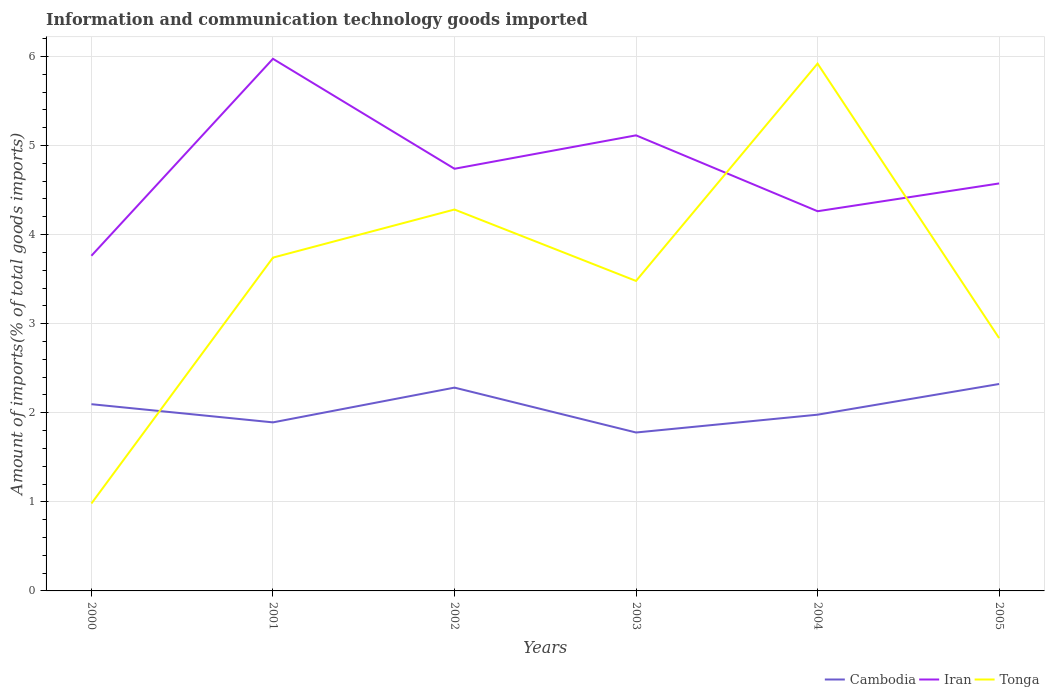Does the line corresponding to Iran intersect with the line corresponding to Cambodia?
Keep it short and to the point. No. Is the number of lines equal to the number of legend labels?
Your answer should be very brief. Yes. Across all years, what is the maximum amount of goods imported in Cambodia?
Make the answer very short. 1.78. What is the total amount of goods imported in Cambodia in the graph?
Make the answer very short. -0.54. What is the difference between the highest and the second highest amount of goods imported in Iran?
Give a very brief answer. 2.21. Is the amount of goods imported in Iran strictly greater than the amount of goods imported in Cambodia over the years?
Your answer should be very brief. No. How many lines are there?
Your answer should be compact. 3. What is the difference between two consecutive major ticks on the Y-axis?
Provide a succinct answer. 1. Where does the legend appear in the graph?
Ensure brevity in your answer.  Bottom right. How many legend labels are there?
Ensure brevity in your answer.  3. What is the title of the graph?
Make the answer very short. Information and communication technology goods imported. What is the label or title of the Y-axis?
Offer a terse response. Amount of imports(% of total goods imports). What is the Amount of imports(% of total goods imports) of Cambodia in 2000?
Provide a succinct answer. 2.1. What is the Amount of imports(% of total goods imports) in Iran in 2000?
Your answer should be very brief. 3.76. What is the Amount of imports(% of total goods imports) of Tonga in 2000?
Make the answer very short. 0.98. What is the Amount of imports(% of total goods imports) in Cambodia in 2001?
Your answer should be compact. 1.89. What is the Amount of imports(% of total goods imports) of Iran in 2001?
Your response must be concise. 5.97. What is the Amount of imports(% of total goods imports) of Tonga in 2001?
Your response must be concise. 3.74. What is the Amount of imports(% of total goods imports) of Cambodia in 2002?
Give a very brief answer. 2.28. What is the Amount of imports(% of total goods imports) in Iran in 2002?
Give a very brief answer. 4.74. What is the Amount of imports(% of total goods imports) of Tonga in 2002?
Give a very brief answer. 4.28. What is the Amount of imports(% of total goods imports) of Cambodia in 2003?
Offer a very short reply. 1.78. What is the Amount of imports(% of total goods imports) of Iran in 2003?
Offer a terse response. 5.11. What is the Amount of imports(% of total goods imports) of Tonga in 2003?
Ensure brevity in your answer.  3.48. What is the Amount of imports(% of total goods imports) of Cambodia in 2004?
Your answer should be compact. 1.98. What is the Amount of imports(% of total goods imports) in Iran in 2004?
Offer a very short reply. 4.26. What is the Amount of imports(% of total goods imports) in Tonga in 2004?
Keep it short and to the point. 5.92. What is the Amount of imports(% of total goods imports) in Cambodia in 2005?
Your answer should be compact. 2.32. What is the Amount of imports(% of total goods imports) in Iran in 2005?
Offer a terse response. 4.57. What is the Amount of imports(% of total goods imports) in Tonga in 2005?
Make the answer very short. 2.84. Across all years, what is the maximum Amount of imports(% of total goods imports) in Cambodia?
Your answer should be very brief. 2.32. Across all years, what is the maximum Amount of imports(% of total goods imports) of Iran?
Your answer should be compact. 5.97. Across all years, what is the maximum Amount of imports(% of total goods imports) of Tonga?
Ensure brevity in your answer.  5.92. Across all years, what is the minimum Amount of imports(% of total goods imports) of Cambodia?
Make the answer very short. 1.78. Across all years, what is the minimum Amount of imports(% of total goods imports) in Iran?
Keep it short and to the point. 3.76. Across all years, what is the minimum Amount of imports(% of total goods imports) of Tonga?
Your response must be concise. 0.98. What is the total Amount of imports(% of total goods imports) of Cambodia in the graph?
Provide a succinct answer. 12.35. What is the total Amount of imports(% of total goods imports) in Iran in the graph?
Your answer should be very brief. 28.43. What is the total Amount of imports(% of total goods imports) in Tonga in the graph?
Make the answer very short. 21.24. What is the difference between the Amount of imports(% of total goods imports) in Cambodia in 2000 and that in 2001?
Keep it short and to the point. 0.2. What is the difference between the Amount of imports(% of total goods imports) of Iran in 2000 and that in 2001?
Offer a very short reply. -2.21. What is the difference between the Amount of imports(% of total goods imports) of Tonga in 2000 and that in 2001?
Keep it short and to the point. -2.76. What is the difference between the Amount of imports(% of total goods imports) in Cambodia in 2000 and that in 2002?
Offer a very short reply. -0.19. What is the difference between the Amount of imports(% of total goods imports) of Iran in 2000 and that in 2002?
Your response must be concise. -0.98. What is the difference between the Amount of imports(% of total goods imports) of Tonga in 2000 and that in 2002?
Ensure brevity in your answer.  -3.3. What is the difference between the Amount of imports(% of total goods imports) in Cambodia in 2000 and that in 2003?
Provide a short and direct response. 0.32. What is the difference between the Amount of imports(% of total goods imports) in Iran in 2000 and that in 2003?
Give a very brief answer. -1.35. What is the difference between the Amount of imports(% of total goods imports) of Tonga in 2000 and that in 2003?
Your response must be concise. -2.5. What is the difference between the Amount of imports(% of total goods imports) of Cambodia in 2000 and that in 2004?
Offer a very short reply. 0.12. What is the difference between the Amount of imports(% of total goods imports) of Tonga in 2000 and that in 2004?
Provide a succinct answer. -4.94. What is the difference between the Amount of imports(% of total goods imports) in Cambodia in 2000 and that in 2005?
Offer a terse response. -0.23. What is the difference between the Amount of imports(% of total goods imports) in Iran in 2000 and that in 2005?
Give a very brief answer. -0.81. What is the difference between the Amount of imports(% of total goods imports) of Tonga in 2000 and that in 2005?
Offer a terse response. -1.86. What is the difference between the Amount of imports(% of total goods imports) of Cambodia in 2001 and that in 2002?
Keep it short and to the point. -0.39. What is the difference between the Amount of imports(% of total goods imports) in Iran in 2001 and that in 2002?
Give a very brief answer. 1.23. What is the difference between the Amount of imports(% of total goods imports) of Tonga in 2001 and that in 2002?
Your answer should be compact. -0.54. What is the difference between the Amount of imports(% of total goods imports) in Cambodia in 2001 and that in 2003?
Keep it short and to the point. 0.11. What is the difference between the Amount of imports(% of total goods imports) of Iran in 2001 and that in 2003?
Provide a succinct answer. 0.86. What is the difference between the Amount of imports(% of total goods imports) of Tonga in 2001 and that in 2003?
Provide a short and direct response. 0.26. What is the difference between the Amount of imports(% of total goods imports) of Cambodia in 2001 and that in 2004?
Ensure brevity in your answer.  -0.09. What is the difference between the Amount of imports(% of total goods imports) in Iran in 2001 and that in 2004?
Keep it short and to the point. 1.71. What is the difference between the Amount of imports(% of total goods imports) in Tonga in 2001 and that in 2004?
Offer a very short reply. -2.18. What is the difference between the Amount of imports(% of total goods imports) of Cambodia in 2001 and that in 2005?
Ensure brevity in your answer.  -0.43. What is the difference between the Amount of imports(% of total goods imports) of Iran in 2001 and that in 2005?
Your answer should be very brief. 1.4. What is the difference between the Amount of imports(% of total goods imports) of Tonga in 2001 and that in 2005?
Make the answer very short. 0.9. What is the difference between the Amount of imports(% of total goods imports) of Cambodia in 2002 and that in 2003?
Your answer should be compact. 0.5. What is the difference between the Amount of imports(% of total goods imports) in Iran in 2002 and that in 2003?
Make the answer very short. -0.38. What is the difference between the Amount of imports(% of total goods imports) in Tonga in 2002 and that in 2003?
Give a very brief answer. 0.8. What is the difference between the Amount of imports(% of total goods imports) of Cambodia in 2002 and that in 2004?
Give a very brief answer. 0.3. What is the difference between the Amount of imports(% of total goods imports) in Iran in 2002 and that in 2004?
Keep it short and to the point. 0.48. What is the difference between the Amount of imports(% of total goods imports) in Tonga in 2002 and that in 2004?
Ensure brevity in your answer.  -1.64. What is the difference between the Amount of imports(% of total goods imports) in Cambodia in 2002 and that in 2005?
Your answer should be very brief. -0.04. What is the difference between the Amount of imports(% of total goods imports) of Iran in 2002 and that in 2005?
Offer a terse response. 0.16. What is the difference between the Amount of imports(% of total goods imports) of Tonga in 2002 and that in 2005?
Ensure brevity in your answer.  1.44. What is the difference between the Amount of imports(% of total goods imports) in Cambodia in 2003 and that in 2004?
Provide a short and direct response. -0.2. What is the difference between the Amount of imports(% of total goods imports) in Iran in 2003 and that in 2004?
Provide a succinct answer. 0.85. What is the difference between the Amount of imports(% of total goods imports) in Tonga in 2003 and that in 2004?
Provide a succinct answer. -2.44. What is the difference between the Amount of imports(% of total goods imports) in Cambodia in 2003 and that in 2005?
Offer a terse response. -0.54. What is the difference between the Amount of imports(% of total goods imports) of Iran in 2003 and that in 2005?
Give a very brief answer. 0.54. What is the difference between the Amount of imports(% of total goods imports) in Tonga in 2003 and that in 2005?
Keep it short and to the point. 0.64. What is the difference between the Amount of imports(% of total goods imports) of Cambodia in 2004 and that in 2005?
Provide a short and direct response. -0.34. What is the difference between the Amount of imports(% of total goods imports) of Iran in 2004 and that in 2005?
Provide a succinct answer. -0.31. What is the difference between the Amount of imports(% of total goods imports) of Tonga in 2004 and that in 2005?
Provide a short and direct response. 3.08. What is the difference between the Amount of imports(% of total goods imports) of Cambodia in 2000 and the Amount of imports(% of total goods imports) of Iran in 2001?
Offer a terse response. -3.88. What is the difference between the Amount of imports(% of total goods imports) of Cambodia in 2000 and the Amount of imports(% of total goods imports) of Tonga in 2001?
Offer a very short reply. -1.65. What is the difference between the Amount of imports(% of total goods imports) in Iran in 2000 and the Amount of imports(% of total goods imports) in Tonga in 2001?
Offer a very short reply. 0.02. What is the difference between the Amount of imports(% of total goods imports) of Cambodia in 2000 and the Amount of imports(% of total goods imports) of Iran in 2002?
Give a very brief answer. -2.64. What is the difference between the Amount of imports(% of total goods imports) of Cambodia in 2000 and the Amount of imports(% of total goods imports) of Tonga in 2002?
Your response must be concise. -2.19. What is the difference between the Amount of imports(% of total goods imports) in Iran in 2000 and the Amount of imports(% of total goods imports) in Tonga in 2002?
Give a very brief answer. -0.52. What is the difference between the Amount of imports(% of total goods imports) in Cambodia in 2000 and the Amount of imports(% of total goods imports) in Iran in 2003?
Make the answer very short. -3.02. What is the difference between the Amount of imports(% of total goods imports) of Cambodia in 2000 and the Amount of imports(% of total goods imports) of Tonga in 2003?
Provide a succinct answer. -1.38. What is the difference between the Amount of imports(% of total goods imports) in Iran in 2000 and the Amount of imports(% of total goods imports) in Tonga in 2003?
Make the answer very short. 0.28. What is the difference between the Amount of imports(% of total goods imports) of Cambodia in 2000 and the Amount of imports(% of total goods imports) of Iran in 2004?
Offer a terse response. -2.17. What is the difference between the Amount of imports(% of total goods imports) in Cambodia in 2000 and the Amount of imports(% of total goods imports) in Tonga in 2004?
Ensure brevity in your answer.  -3.82. What is the difference between the Amount of imports(% of total goods imports) in Iran in 2000 and the Amount of imports(% of total goods imports) in Tonga in 2004?
Ensure brevity in your answer.  -2.16. What is the difference between the Amount of imports(% of total goods imports) in Cambodia in 2000 and the Amount of imports(% of total goods imports) in Iran in 2005?
Your answer should be very brief. -2.48. What is the difference between the Amount of imports(% of total goods imports) of Cambodia in 2000 and the Amount of imports(% of total goods imports) of Tonga in 2005?
Make the answer very short. -0.74. What is the difference between the Amount of imports(% of total goods imports) in Iran in 2000 and the Amount of imports(% of total goods imports) in Tonga in 2005?
Your answer should be compact. 0.92. What is the difference between the Amount of imports(% of total goods imports) in Cambodia in 2001 and the Amount of imports(% of total goods imports) in Iran in 2002?
Keep it short and to the point. -2.85. What is the difference between the Amount of imports(% of total goods imports) of Cambodia in 2001 and the Amount of imports(% of total goods imports) of Tonga in 2002?
Provide a succinct answer. -2.39. What is the difference between the Amount of imports(% of total goods imports) of Iran in 2001 and the Amount of imports(% of total goods imports) of Tonga in 2002?
Give a very brief answer. 1.69. What is the difference between the Amount of imports(% of total goods imports) in Cambodia in 2001 and the Amount of imports(% of total goods imports) in Iran in 2003?
Offer a terse response. -3.22. What is the difference between the Amount of imports(% of total goods imports) of Cambodia in 2001 and the Amount of imports(% of total goods imports) of Tonga in 2003?
Your response must be concise. -1.59. What is the difference between the Amount of imports(% of total goods imports) of Iran in 2001 and the Amount of imports(% of total goods imports) of Tonga in 2003?
Your answer should be compact. 2.49. What is the difference between the Amount of imports(% of total goods imports) in Cambodia in 2001 and the Amount of imports(% of total goods imports) in Iran in 2004?
Provide a succinct answer. -2.37. What is the difference between the Amount of imports(% of total goods imports) of Cambodia in 2001 and the Amount of imports(% of total goods imports) of Tonga in 2004?
Your answer should be very brief. -4.03. What is the difference between the Amount of imports(% of total goods imports) in Iran in 2001 and the Amount of imports(% of total goods imports) in Tonga in 2004?
Provide a succinct answer. 0.05. What is the difference between the Amount of imports(% of total goods imports) of Cambodia in 2001 and the Amount of imports(% of total goods imports) of Iran in 2005?
Ensure brevity in your answer.  -2.68. What is the difference between the Amount of imports(% of total goods imports) in Cambodia in 2001 and the Amount of imports(% of total goods imports) in Tonga in 2005?
Provide a succinct answer. -0.95. What is the difference between the Amount of imports(% of total goods imports) of Iran in 2001 and the Amount of imports(% of total goods imports) of Tonga in 2005?
Make the answer very short. 3.14. What is the difference between the Amount of imports(% of total goods imports) of Cambodia in 2002 and the Amount of imports(% of total goods imports) of Iran in 2003?
Ensure brevity in your answer.  -2.83. What is the difference between the Amount of imports(% of total goods imports) in Cambodia in 2002 and the Amount of imports(% of total goods imports) in Tonga in 2003?
Provide a short and direct response. -1.2. What is the difference between the Amount of imports(% of total goods imports) of Iran in 2002 and the Amount of imports(% of total goods imports) of Tonga in 2003?
Your answer should be very brief. 1.26. What is the difference between the Amount of imports(% of total goods imports) in Cambodia in 2002 and the Amount of imports(% of total goods imports) in Iran in 2004?
Give a very brief answer. -1.98. What is the difference between the Amount of imports(% of total goods imports) in Cambodia in 2002 and the Amount of imports(% of total goods imports) in Tonga in 2004?
Your answer should be very brief. -3.64. What is the difference between the Amount of imports(% of total goods imports) of Iran in 2002 and the Amount of imports(% of total goods imports) of Tonga in 2004?
Ensure brevity in your answer.  -1.18. What is the difference between the Amount of imports(% of total goods imports) of Cambodia in 2002 and the Amount of imports(% of total goods imports) of Iran in 2005?
Offer a very short reply. -2.29. What is the difference between the Amount of imports(% of total goods imports) of Cambodia in 2002 and the Amount of imports(% of total goods imports) of Tonga in 2005?
Give a very brief answer. -0.56. What is the difference between the Amount of imports(% of total goods imports) in Iran in 2002 and the Amount of imports(% of total goods imports) in Tonga in 2005?
Provide a short and direct response. 1.9. What is the difference between the Amount of imports(% of total goods imports) of Cambodia in 2003 and the Amount of imports(% of total goods imports) of Iran in 2004?
Offer a very short reply. -2.48. What is the difference between the Amount of imports(% of total goods imports) of Cambodia in 2003 and the Amount of imports(% of total goods imports) of Tonga in 2004?
Give a very brief answer. -4.14. What is the difference between the Amount of imports(% of total goods imports) of Iran in 2003 and the Amount of imports(% of total goods imports) of Tonga in 2004?
Keep it short and to the point. -0.81. What is the difference between the Amount of imports(% of total goods imports) of Cambodia in 2003 and the Amount of imports(% of total goods imports) of Iran in 2005?
Ensure brevity in your answer.  -2.8. What is the difference between the Amount of imports(% of total goods imports) in Cambodia in 2003 and the Amount of imports(% of total goods imports) in Tonga in 2005?
Make the answer very short. -1.06. What is the difference between the Amount of imports(% of total goods imports) of Iran in 2003 and the Amount of imports(% of total goods imports) of Tonga in 2005?
Your answer should be very brief. 2.28. What is the difference between the Amount of imports(% of total goods imports) of Cambodia in 2004 and the Amount of imports(% of total goods imports) of Iran in 2005?
Keep it short and to the point. -2.6. What is the difference between the Amount of imports(% of total goods imports) in Cambodia in 2004 and the Amount of imports(% of total goods imports) in Tonga in 2005?
Offer a very short reply. -0.86. What is the difference between the Amount of imports(% of total goods imports) in Iran in 2004 and the Amount of imports(% of total goods imports) in Tonga in 2005?
Offer a very short reply. 1.42. What is the average Amount of imports(% of total goods imports) in Cambodia per year?
Offer a terse response. 2.06. What is the average Amount of imports(% of total goods imports) of Iran per year?
Make the answer very short. 4.74. What is the average Amount of imports(% of total goods imports) in Tonga per year?
Ensure brevity in your answer.  3.54. In the year 2000, what is the difference between the Amount of imports(% of total goods imports) in Cambodia and Amount of imports(% of total goods imports) in Iran?
Your response must be concise. -1.67. In the year 2000, what is the difference between the Amount of imports(% of total goods imports) in Cambodia and Amount of imports(% of total goods imports) in Tonga?
Your response must be concise. 1.11. In the year 2000, what is the difference between the Amount of imports(% of total goods imports) in Iran and Amount of imports(% of total goods imports) in Tonga?
Make the answer very short. 2.78. In the year 2001, what is the difference between the Amount of imports(% of total goods imports) in Cambodia and Amount of imports(% of total goods imports) in Iran?
Your answer should be very brief. -4.08. In the year 2001, what is the difference between the Amount of imports(% of total goods imports) in Cambodia and Amount of imports(% of total goods imports) in Tonga?
Make the answer very short. -1.85. In the year 2001, what is the difference between the Amount of imports(% of total goods imports) of Iran and Amount of imports(% of total goods imports) of Tonga?
Offer a very short reply. 2.23. In the year 2002, what is the difference between the Amount of imports(% of total goods imports) in Cambodia and Amount of imports(% of total goods imports) in Iran?
Your answer should be very brief. -2.46. In the year 2002, what is the difference between the Amount of imports(% of total goods imports) of Cambodia and Amount of imports(% of total goods imports) of Tonga?
Keep it short and to the point. -2. In the year 2002, what is the difference between the Amount of imports(% of total goods imports) in Iran and Amount of imports(% of total goods imports) in Tonga?
Your answer should be compact. 0.46. In the year 2003, what is the difference between the Amount of imports(% of total goods imports) in Cambodia and Amount of imports(% of total goods imports) in Iran?
Provide a short and direct response. -3.34. In the year 2003, what is the difference between the Amount of imports(% of total goods imports) of Cambodia and Amount of imports(% of total goods imports) of Tonga?
Offer a terse response. -1.7. In the year 2003, what is the difference between the Amount of imports(% of total goods imports) of Iran and Amount of imports(% of total goods imports) of Tonga?
Provide a short and direct response. 1.63. In the year 2004, what is the difference between the Amount of imports(% of total goods imports) in Cambodia and Amount of imports(% of total goods imports) in Iran?
Your answer should be compact. -2.28. In the year 2004, what is the difference between the Amount of imports(% of total goods imports) of Cambodia and Amount of imports(% of total goods imports) of Tonga?
Your response must be concise. -3.94. In the year 2004, what is the difference between the Amount of imports(% of total goods imports) of Iran and Amount of imports(% of total goods imports) of Tonga?
Ensure brevity in your answer.  -1.66. In the year 2005, what is the difference between the Amount of imports(% of total goods imports) in Cambodia and Amount of imports(% of total goods imports) in Iran?
Provide a succinct answer. -2.25. In the year 2005, what is the difference between the Amount of imports(% of total goods imports) of Cambodia and Amount of imports(% of total goods imports) of Tonga?
Offer a very short reply. -0.52. In the year 2005, what is the difference between the Amount of imports(% of total goods imports) of Iran and Amount of imports(% of total goods imports) of Tonga?
Provide a short and direct response. 1.74. What is the ratio of the Amount of imports(% of total goods imports) in Cambodia in 2000 to that in 2001?
Your answer should be compact. 1.11. What is the ratio of the Amount of imports(% of total goods imports) of Iran in 2000 to that in 2001?
Offer a very short reply. 0.63. What is the ratio of the Amount of imports(% of total goods imports) in Tonga in 2000 to that in 2001?
Provide a short and direct response. 0.26. What is the ratio of the Amount of imports(% of total goods imports) of Cambodia in 2000 to that in 2002?
Your answer should be compact. 0.92. What is the ratio of the Amount of imports(% of total goods imports) of Iran in 2000 to that in 2002?
Offer a very short reply. 0.79. What is the ratio of the Amount of imports(% of total goods imports) of Tonga in 2000 to that in 2002?
Provide a short and direct response. 0.23. What is the ratio of the Amount of imports(% of total goods imports) in Cambodia in 2000 to that in 2003?
Give a very brief answer. 1.18. What is the ratio of the Amount of imports(% of total goods imports) in Iran in 2000 to that in 2003?
Give a very brief answer. 0.74. What is the ratio of the Amount of imports(% of total goods imports) in Tonga in 2000 to that in 2003?
Give a very brief answer. 0.28. What is the ratio of the Amount of imports(% of total goods imports) in Cambodia in 2000 to that in 2004?
Ensure brevity in your answer.  1.06. What is the ratio of the Amount of imports(% of total goods imports) of Iran in 2000 to that in 2004?
Make the answer very short. 0.88. What is the ratio of the Amount of imports(% of total goods imports) in Tonga in 2000 to that in 2004?
Ensure brevity in your answer.  0.17. What is the ratio of the Amount of imports(% of total goods imports) in Cambodia in 2000 to that in 2005?
Offer a terse response. 0.9. What is the ratio of the Amount of imports(% of total goods imports) of Iran in 2000 to that in 2005?
Your answer should be compact. 0.82. What is the ratio of the Amount of imports(% of total goods imports) of Tonga in 2000 to that in 2005?
Provide a succinct answer. 0.35. What is the ratio of the Amount of imports(% of total goods imports) of Cambodia in 2001 to that in 2002?
Offer a very short reply. 0.83. What is the ratio of the Amount of imports(% of total goods imports) of Iran in 2001 to that in 2002?
Your answer should be very brief. 1.26. What is the ratio of the Amount of imports(% of total goods imports) in Tonga in 2001 to that in 2002?
Offer a terse response. 0.87. What is the ratio of the Amount of imports(% of total goods imports) of Cambodia in 2001 to that in 2003?
Provide a short and direct response. 1.06. What is the ratio of the Amount of imports(% of total goods imports) in Iran in 2001 to that in 2003?
Your response must be concise. 1.17. What is the ratio of the Amount of imports(% of total goods imports) in Tonga in 2001 to that in 2003?
Your answer should be very brief. 1.08. What is the ratio of the Amount of imports(% of total goods imports) in Cambodia in 2001 to that in 2004?
Your answer should be very brief. 0.96. What is the ratio of the Amount of imports(% of total goods imports) in Iran in 2001 to that in 2004?
Make the answer very short. 1.4. What is the ratio of the Amount of imports(% of total goods imports) in Tonga in 2001 to that in 2004?
Make the answer very short. 0.63. What is the ratio of the Amount of imports(% of total goods imports) of Cambodia in 2001 to that in 2005?
Keep it short and to the point. 0.81. What is the ratio of the Amount of imports(% of total goods imports) in Iran in 2001 to that in 2005?
Give a very brief answer. 1.31. What is the ratio of the Amount of imports(% of total goods imports) in Tonga in 2001 to that in 2005?
Make the answer very short. 1.32. What is the ratio of the Amount of imports(% of total goods imports) of Cambodia in 2002 to that in 2003?
Ensure brevity in your answer.  1.28. What is the ratio of the Amount of imports(% of total goods imports) in Iran in 2002 to that in 2003?
Give a very brief answer. 0.93. What is the ratio of the Amount of imports(% of total goods imports) in Tonga in 2002 to that in 2003?
Your response must be concise. 1.23. What is the ratio of the Amount of imports(% of total goods imports) in Cambodia in 2002 to that in 2004?
Your answer should be compact. 1.15. What is the ratio of the Amount of imports(% of total goods imports) in Iran in 2002 to that in 2004?
Your answer should be very brief. 1.11. What is the ratio of the Amount of imports(% of total goods imports) of Tonga in 2002 to that in 2004?
Make the answer very short. 0.72. What is the ratio of the Amount of imports(% of total goods imports) of Cambodia in 2002 to that in 2005?
Your answer should be very brief. 0.98. What is the ratio of the Amount of imports(% of total goods imports) of Iran in 2002 to that in 2005?
Your answer should be compact. 1.04. What is the ratio of the Amount of imports(% of total goods imports) in Tonga in 2002 to that in 2005?
Provide a succinct answer. 1.51. What is the ratio of the Amount of imports(% of total goods imports) in Cambodia in 2003 to that in 2004?
Offer a terse response. 0.9. What is the ratio of the Amount of imports(% of total goods imports) of Iran in 2003 to that in 2004?
Ensure brevity in your answer.  1.2. What is the ratio of the Amount of imports(% of total goods imports) of Tonga in 2003 to that in 2004?
Offer a very short reply. 0.59. What is the ratio of the Amount of imports(% of total goods imports) of Cambodia in 2003 to that in 2005?
Provide a short and direct response. 0.77. What is the ratio of the Amount of imports(% of total goods imports) of Iran in 2003 to that in 2005?
Your answer should be very brief. 1.12. What is the ratio of the Amount of imports(% of total goods imports) in Tonga in 2003 to that in 2005?
Offer a very short reply. 1.23. What is the ratio of the Amount of imports(% of total goods imports) in Cambodia in 2004 to that in 2005?
Offer a terse response. 0.85. What is the ratio of the Amount of imports(% of total goods imports) in Iran in 2004 to that in 2005?
Make the answer very short. 0.93. What is the ratio of the Amount of imports(% of total goods imports) in Tonga in 2004 to that in 2005?
Offer a very short reply. 2.09. What is the difference between the highest and the second highest Amount of imports(% of total goods imports) in Cambodia?
Provide a succinct answer. 0.04. What is the difference between the highest and the second highest Amount of imports(% of total goods imports) of Iran?
Your response must be concise. 0.86. What is the difference between the highest and the second highest Amount of imports(% of total goods imports) in Tonga?
Offer a terse response. 1.64. What is the difference between the highest and the lowest Amount of imports(% of total goods imports) in Cambodia?
Your answer should be compact. 0.54. What is the difference between the highest and the lowest Amount of imports(% of total goods imports) of Iran?
Your answer should be compact. 2.21. What is the difference between the highest and the lowest Amount of imports(% of total goods imports) in Tonga?
Offer a very short reply. 4.94. 